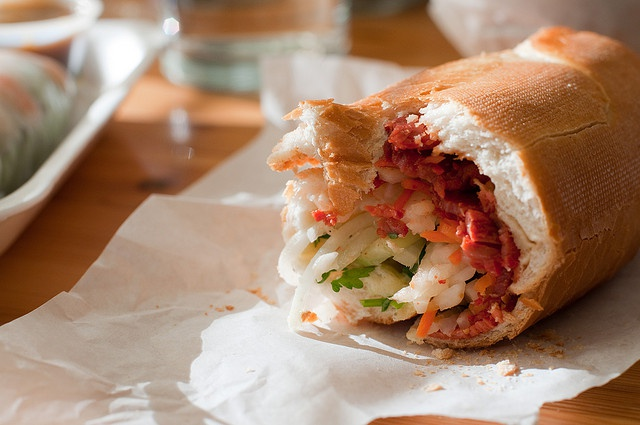Describe the objects in this image and their specific colors. I can see dining table in tan, lightgray, and maroon tones, sandwich in tan, maroon, brown, and lightgray tones, and cup in tan, darkgray, brown, and gray tones in this image. 